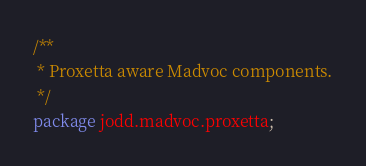Convert code to text. <code><loc_0><loc_0><loc_500><loc_500><_Java_>/**
 * Proxetta aware Madvoc components.
 */
package jodd.madvoc.proxetta;</code> 